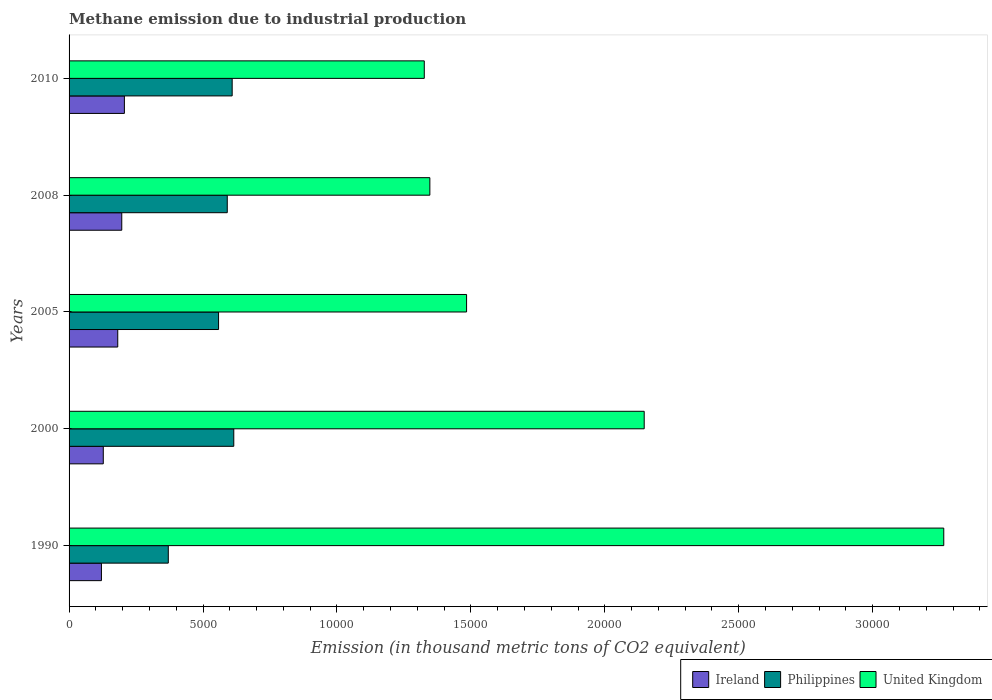How many different coloured bars are there?
Provide a succinct answer. 3. How many groups of bars are there?
Ensure brevity in your answer.  5. Are the number of bars per tick equal to the number of legend labels?
Ensure brevity in your answer.  Yes. How many bars are there on the 4th tick from the top?
Provide a short and direct response. 3. How many bars are there on the 4th tick from the bottom?
Ensure brevity in your answer.  3. What is the label of the 2nd group of bars from the top?
Give a very brief answer. 2008. What is the amount of methane emitted in Ireland in 2010?
Provide a short and direct response. 2065.3. Across all years, what is the maximum amount of methane emitted in Philippines?
Provide a succinct answer. 6149.1. Across all years, what is the minimum amount of methane emitted in United Kingdom?
Provide a short and direct response. 1.33e+04. In which year was the amount of methane emitted in Ireland maximum?
Your answer should be very brief. 2010. What is the total amount of methane emitted in United Kingdom in the graph?
Offer a terse response. 9.57e+04. What is the difference between the amount of methane emitted in Ireland in 2000 and that in 2010?
Give a very brief answer. -788.4. What is the difference between the amount of methane emitted in Ireland in 2000 and the amount of methane emitted in United Kingdom in 2008?
Your answer should be very brief. -1.22e+04. What is the average amount of methane emitted in Ireland per year?
Ensure brevity in your answer.  1667.04. In the year 2000, what is the difference between the amount of methane emitted in United Kingdom and amount of methane emitted in Philippines?
Give a very brief answer. 1.53e+04. In how many years, is the amount of methane emitted in United Kingdom greater than 3000 thousand metric tons?
Make the answer very short. 5. What is the ratio of the amount of methane emitted in United Kingdom in 2000 to that in 2005?
Keep it short and to the point. 1.45. Is the amount of methane emitted in Philippines in 2000 less than that in 2005?
Ensure brevity in your answer.  No. Is the difference between the amount of methane emitted in United Kingdom in 1990 and 2008 greater than the difference between the amount of methane emitted in Philippines in 1990 and 2008?
Give a very brief answer. Yes. What is the difference between the highest and the second highest amount of methane emitted in Ireland?
Offer a very short reply. 98.2. What is the difference between the highest and the lowest amount of methane emitted in Ireland?
Your answer should be very brief. 856.9. In how many years, is the amount of methane emitted in Ireland greater than the average amount of methane emitted in Ireland taken over all years?
Your response must be concise. 3. Is the sum of the amount of methane emitted in Ireland in 1990 and 2000 greater than the maximum amount of methane emitted in United Kingdom across all years?
Your response must be concise. No. Is it the case that in every year, the sum of the amount of methane emitted in Philippines and amount of methane emitted in Ireland is greater than the amount of methane emitted in United Kingdom?
Provide a short and direct response. No. How many bars are there?
Your response must be concise. 15. What is the difference between two consecutive major ticks on the X-axis?
Offer a very short reply. 5000. Where does the legend appear in the graph?
Give a very brief answer. Bottom right. What is the title of the graph?
Give a very brief answer. Methane emission due to industrial production. Does "High income" appear as one of the legend labels in the graph?
Your response must be concise. No. What is the label or title of the X-axis?
Ensure brevity in your answer.  Emission (in thousand metric tons of CO2 equivalent). What is the Emission (in thousand metric tons of CO2 equivalent) in Ireland in 1990?
Give a very brief answer. 1208.4. What is the Emission (in thousand metric tons of CO2 equivalent) in Philippines in 1990?
Keep it short and to the point. 3704.2. What is the Emission (in thousand metric tons of CO2 equivalent) in United Kingdom in 1990?
Your answer should be very brief. 3.27e+04. What is the Emission (in thousand metric tons of CO2 equivalent) in Ireland in 2000?
Offer a very short reply. 1276.9. What is the Emission (in thousand metric tons of CO2 equivalent) in Philippines in 2000?
Offer a very short reply. 6149.1. What is the Emission (in thousand metric tons of CO2 equivalent) in United Kingdom in 2000?
Keep it short and to the point. 2.15e+04. What is the Emission (in thousand metric tons of CO2 equivalent) in Ireland in 2005?
Offer a very short reply. 1817.5. What is the Emission (in thousand metric tons of CO2 equivalent) of Philippines in 2005?
Ensure brevity in your answer.  5580.9. What is the Emission (in thousand metric tons of CO2 equivalent) of United Kingdom in 2005?
Provide a short and direct response. 1.48e+04. What is the Emission (in thousand metric tons of CO2 equivalent) in Ireland in 2008?
Offer a terse response. 1967.1. What is the Emission (in thousand metric tons of CO2 equivalent) of Philippines in 2008?
Provide a succinct answer. 5905.9. What is the Emission (in thousand metric tons of CO2 equivalent) in United Kingdom in 2008?
Ensure brevity in your answer.  1.35e+04. What is the Emission (in thousand metric tons of CO2 equivalent) in Ireland in 2010?
Offer a terse response. 2065.3. What is the Emission (in thousand metric tons of CO2 equivalent) in Philippines in 2010?
Your response must be concise. 6088.8. What is the Emission (in thousand metric tons of CO2 equivalent) of United Kingdom in 2010?
Keep it short and to the point. 1.33e+04. Across all years, what is the maximum Emission (in thousand metric tons of CO2 equivalent) in Ireland?
Make the answer very short. 2065.3. Across all years, what is the maximum Emission (in thousand metric tons of CO2 equivalent) in Philippines?
Offer a terse response. 6149.1. Across all years, what is the maximum Emission (in thousand metric tons of CO2 equivalent) in United Kingdom?
Ensure brevity in your answer.  3.27e+04. Across all years, what is the minimum Emission (in thousand metric tons of CO2 equivalent) in Ireland?
Ensure brevity in your answer.  1208.4. Across all years, what is the minimum Emission (in thousand metric tons of CO2 equivalent) in Philippines?
Give a very brief answer. 3704.2. Across all years, what is the minimum Emission (in thousand metric tons of CO2 equivalent) of United Kingdom?
Provide a short and direct response. 1.33e+04. What is the total Emission (in thousand metric tons of CO2 equivalent) in Ireland in the graph?
Your answer should be very brief. 8335.2. What is the total Emission (in thousand metric tons of CO2 equivalent) of Philippines in the graph?
Give a very brief answer. 2.74e+04. What is the total Emission (in thousand metric tons of CO2 equivalent) in United Kingdom in the graph?
Your answer should be compact. 9.57e+04. What is the difference between the Emission (in thousand metric tons of CO2 equivalent) of Ireland in 1990 and that in 2000?
Your answer should be very brief. -68.5. What is the difference between the Emission (in thousand metric tons of CO2 equivalent) in Philippines in 1990 and that in 2000?
Provide a short and direct response. -2444.9. What is the difference between the Emission (in thousand metric tons of CO2 equivalent) in United Kingdom in 1990 and that in 2000?
Ensure brevity in your answer.  1.12e+04. What is the difference between the Emission (in thousand metric tons of CO2 equivalent) of Ireland in 1990 and that in 2005?
Offer a terse response. -609.1. What is the difference between the Emission (in thousand metric tons of CO2 equivalent) in Philippines in 1990 and that in 2005?
Ensure brevity in your answer.  -1876.7. What is the difference between the Emission (in thousand metric tons of CO2 equivalent) in United Kingdom in 1990 and that in 2005?
Provide a succinct answer. 1.78e+04. What is the difference between the Emission (in thousand metric tons of CO2 equivalent) in Ireland in 1990 and that in 2008?
Keep it short and to the point. -758.7. What is the difference between the Emission (in thousand metric tons of CO2 equivalent) of Philippines in 1990 and that in 2008?
Keep it short and to the point. -2201.7. What is the difference between the Emission (in thousand metric tons of CO2 equivalent) in United Kingdom in 1990 and that in 2008?
Your response must be concise. 1.92e+04. What is the difference between the Emission (in thousand metric tons of CO2 equivalent) in Ireland in 1990 and that in 2010?
Your response must be concise. -856.9. What is the difference between the Emission (in thousand metric tons of CO2 equivalent) in Philippines in 1990 and that in 2010?
Offer a terse response. -2384.6. What is the difference between the Emission (in thousand metric tons of CO2 equivalent) in United Kingdom in 1990 and that in 2010?
Provide a short and direct response. 1.94e+04. What is the difference between the Emission (in thousand metric tons of CO2 equivalent) in Ireland in 2000 and that in 2005?
Ensure brevity in your answer.  -540.6. What is the difference between the Emission (in thousand metric tons of CO2 equivalent) in Philippines in 2000 and that in 2005?
Offer a very short reply. 568.2. What is the difference between the Emission (in thousand metric tons of CO2 equivalent) in United Kingdom in 2000 and that in 2005?
Make the answer very short. 6631. What is the difference between the Emission (in thousand metric tons of CO2 equivalent) of Ireland in 2000 and that in 2008?
Your answer should be compact. -690.2. What is the difference between the Emission (in thousand metric tons of CO2 equivalent) in Philippines in 2000 and that in 2008?
Ensure brevity in your answer.  243.2. What is the difference between the Emission (in thousand metric tons of CO2 equivalent) in United Kingdom in 2000 and that in 2008?
Offer a terse response. 8001.7. What is the difference between the Emission (in thousand metric tons of CO2 equivalent) in Ireland in 2000 and that in 2010?
Your answer should be compact. -788.4. What is the difference between the Emission (in thousand metric tons of CO2 equivalent) of Philippines in 2000 and that in 2010?
Offer a terse response. 60.3. What is the difference between the Emission (in thousand metric tons of CO2 equivalent) in United Kingdom in 2000 and that in 2010?
Your answer should be very brief. 8210. What is the difference between the Emission (in thousand metric tons of CO2 equivalent) of Ireland in 2005 and that in 2008?
Keep it short and to the point. -149.6. What is the difference between the Emission (in thousand metric tons of CO2 equivalent) in Philippines in 2005 and that in 2008?
Give a very brief answer. -325. What is the difference between the Emission (in thousand metric tons of CO2 equivalent) in United Kingdom in 2005 and that in 2008?
Keep it short and to the point. 1370.7. What is the difference between the Emission (in thousand metric tons of CO2 equivalent) in Ireland in 2005 and that in 2010?
Your answer should be compact. -247.8. What is the difference between the Emission (in thousand metric tons of CO2 equivalent) in Philippines in 2005 and that in 2010?
Offer a very short reply. -507.9. What is the difference between the Emission (in thousand metric tons of CO2 equivalent) in United Kingdom in 2005 and that in 2010?
Your response must be concise. 1579. What is the difference between the Emission (in thousand metric tons of CO2 equivalent) in Ireland in 2008 and that in 2010?
Provide a succinct answer. -98.2. What is the difference between the Emission (in thousand metric tons of CO2 equivalent) in Philippines in 2008 and that in 2010?
Offer a terse response. -182.9. What is the difference between the Emission (in thousand metric tons of CO2 equivalent) in United Kingdom in 2008 and that in 2010?
Your answer should be compact. 208.3. What is the difference between the Emission (in thousand metric tons of CO2 equivalent) in Ireland in 1990 and the Emission (in thousand metric tons of CO2 equivalent) in Philippines in 2000?
Offer a very short reply. -4940.7. What is the difference between the Emission (in thousand metric tons of CO2 equivalent) in Ireland in 1990 and the Emission (in thousand metric tons of CO2 equivalent) in United Kingdom in 2000?
Your answer should be compact. -2.03e+04. What is the difference between the Emission (in thousand metric tons of CO2 equivalent) in Philippines in 1990 and the Emission (in thousand metric tons of CO2 equivalent) in United Kingdom in 2000?
Keep it short and to the point. -1.78e+04. What is the difference between the Emission (in thousand metric tons of CO2 equivalent) in Ireland in 1990 and the Emission (in thousand metric tons of CO2 equivalent) in Philippines in 2005?
Keep it short and to the point. -4372.5. What is the difference between the Emission (in thousand metric tons of CO2 equivalent) of Ireland in 1990 and the Emission (in thousand metric tons of CO2 equivalent) of United Kingdom in 2005?
Your answer should be very brief. -1.36e+04. What is the difference between the Emission (in thousand metric tons of CO2 equivalent) of Philippines in 1990 and the Emission (in thousand metric tons of CO2 equivalent) of United Kingdom in 2005?
Your answer should be compact. -1.11e+04. What is the difference between the Emission (in thousand metric tons of CO2 equivalent) in Ireland in 1990 and the Emission (in thousand metric tons of CO2 equivalent) in Philippines in 2008?
Give a very brief answer. -4697.5. What is the difference between the Emission (in thousand metric tons of CO2 equivalent) in Ireland in 1990 and the Emission (in thousand metric tons of CO2 equivalent) in United Kingdom in 2008?
Keep it short and to the point. -1.23e+04. What is the difference between the Emission (in thousand metric tons of CO2 equivalent) of Philippines in 1990 and the Emission (in thousand metric tons of CO2 equivalent) of United Kingdom in 2008?
Your answer should be very brief. -9764.8. What is the difference between the Emission (in thousand metric tons of CO2 equivalent) in Ireland in 1990 and the Emission (in thousand metric tons of CO2 equivalent) in Philippines in 2010?
Keep it short and to the point. -4880.4. What is the difference between the Emission (in thousand metric tons of CO2 equivalent) in Ireland in 1990 and the Emission (in thousand metric tons of CO2 equivalent) in United Kingdom in 2010?
Offer a very short reply. -1.21e+04. What is the difference between the Emission (in thousand metric tons of CO2 equivalent) of Philippines in 1990 and the Emission (in thousand metric tons of CO2 equivalent) of United Kingdom in 2010?
Offer a very short reply. -9556.5. What is the difference between the Emission (in thousand metric tons of CO2 equivalent) in Ireland in 2000 and the Emission (in thousand metric tons of CO2 equivalent) in Philippines in 2005?
Make the answer very short. -4304. What is the difference between the Emission (in thousand metric tons of CO2 equivalent) in Ireland in 2000 and the Emission (in thousand metric tons of CO2 equivalent) in United Kingdom in 2005?
Your answer should be very brief. -1.36e+04. What is the difference between the Emission (in thousand metric tons of CO2 equivalent) of Philippines in 2000 and the Emission (in thousand metric tons of CO2 equivalent) of United Kingdom in 2005?
Make the answer very short. -8690.6. What is the difference between the Emission (in thousand metric tons of CO2 equivalent) in Ireland in 2000 and the Emission (in thousand metric tons of CO2 equivalent) in Philippines in 2008?
Your answer should be compact. -4629. What is the difference between the Emission (in thousand metric tons of CO2 equivalent) of Ireland in 2000 and the Emission (in thousand metric tons of CO2 equivalent) of United Kingdom in 2008?
Give a very brief answer. -1.22e+04. What is the difference between the Emission (in thousand metric tons of CO2 equivalent) in Philippines in 2000 and the Emission (in thousand metric tons of CO2 equivalent) in United Kingdom in 2008?
Offer a very short reply. -7319.9. What is the difference between the Emission (in thousand metric tons of CO2 equivalent) of Ireland in 2000 and the Emission (in thousand metric tons of CO2 equivalent) of Philippines in 2010?
Your answer should be compact. -4811.9. What is the difference between the Emission (in thousand metric tons of CO2 equivalent) in Ireland in 2000 and the Emission (in thousand metric tons of CO2 equivalent) in United Kingdom in 2010?
Offer a terse response. -1.20e+04. What is the difference between the Emission (in thousand metric tons of CO2 equivalent) of Philippines in 2000 and the Emission (in thousand metric tons of CO2 equivalent) of United Kingdom in 2010?
Your response must be concise. -7111.6. What is the difference between the Emission (in thousand metric tons of CO2 equivalent) of Ireland in 2005 and the Emission (in thousand metric tons of CO2 equivalent) of Philippines in 2008?
Ensure brevity in your answer.  -4088.4. What is the difference between the Emission (in thousand metric tons of CO2 equivalent) in Ireland in 2005 and the Emission (in thousand metric tons of CO2 equivalent) in United Kingdom in 2008?
Provide a short and direct response. -1.17e+04. What is the difference between the Emission (in thousand metric tons of CO2 equivalent) of Philippines in 2005 and the Emission (in thousand metric tons of CO2 equivalent) of United Kingdom in 2008?
Make the answer very short. -7888.1. What is the difference between the Emission (in thousand metric tons of CO2 equivalent) of Ireland in 2005 and the Emission (in thousand metric tons of CO2 equivalent) of Philippines in 2010?
Provide a short and direct response. -4271.3. What is the difference between the Emission (in thousand metric tons of CO2 equivalent) of Ireland in 2005 and the Emission (in thousand metric tons of CO2 equivalent) of United Kingdom in 2010?
Provide a succinct answer. -1.14e+04. What is the difference between the Emission (in thousand metric tons of CO2 equivalent) in Philippines in 2005 and the Emission (in thousand metric tons of CO2 equivalent) in United Kingdom in 2010?
Your answer should be very brief. -7679.8. What is the difference between the Emission (in thousand metric tons of CO2 equivalent) in Ireland in 2008 and the Emission (in thousand metric tons of CO2 equivalent) in Philippines in 2010?
Give a very brief answer. -4121.7. What is the difference between the Emission (in thousand metric tons of CO2 equivalent) of Ireland in 2008 and the Emission (in thousand metric tons of CO2 equivalent) of United Kingdom in 2010?
Ensure brevity in your answer.  -1.13e+04. What is the difference between the Emission (in thousand metric tons of CO2 equivalent) of Philippines in 2008 and the Emission (in thousand metric tons of CO2 equivalent) of United Kingdom in 2010?
Offer a terse response. -7354.8. What is the average Emission (in thousand metric tons of CO2 equivalent) of Ireland per year?
Make the answer very short. 1667.04. What is the average Emission (in thousand metric tons of CO2 equivalent) in Philippines per year?
Give a very brief answer. 5485.78. What is the average Emission (in thousand metric tons of CO2 equivalent) of United Kingdom per year?
Give a very brief answer. 1.91e+04. In the year 1990, what is the difference between the Emission (in thousand metric tons of CO2 equivalent) in Ireland and Emission (in thousand metric tons of CO2 equivalent) in Philippines?
Make the answer very short. -2495.8. In the year 1990, what is the difference between the Emission (in thousand metric tons of CO2 equivalent) in Ireland and Emission (in thousand metric tons of CO2 equivalent) in United Kingdom?
Provide a succinct answer. -3.14e+04. In the year 1990, what is the difference between the Emission (in thousand metric tons of CO2 equivalent) of Philippines and Emission (in thousand metric tons of CO2 equivalent) of United Kingdom?
Your response must be concise. -2.89e+04. In the year 2000, what is the difference between the Emission (in thousand metric tons of CO2 equivalent) in Ireland and Emission (in thousand metric tons of CO2 equivalent) in Philippines?
Your answer should be compact. -4872.2. In the year 2000, what is the difference between the Emission (in thousand metric tons of CO2 equivalent) of Ireland and Emission (in thousand metric tons of CO2 equivalent) of United Kingdom?
Provide a short and direct response. -2.02e+04. In the year 2000, what is the difference between the Emission (in thousand metric tons of CO2 equivalent) of Philippines and Emission (in thousand metric tons of CO2 equivalent) of United Kingdom?
Ensure brevity in your answer.  -1.53e+04. In the year 2005, what is the difference between the Emission (in thousand metric tons of CO2 equivalent) of Ireland and Emission (in thousand metric tons of CO2 equivalent) of Philippines?
Give a very brief answer. -3763.4. In the year 2005, what is the difference between the Emission (in thousand metric tons of CO2 equivalent) in Ireland and Emission (in thousand metric tons of CO2 equivalent) in United Kingdom?
Provide a succinct answer. -1.30e+04. In the year 2005, what is the difference between the Emission (in thousand metric tons of CO2 equivalent) in Philippines and Emission (in thousand metric tons of CO2 equivalent) in United Kingdom?
Your response must be concise. -9258.8. In the year 2008, what is the difference between the Emission (in thousand metric tons of CO2 equivalent) in Ireland and Emission (in thousand metric tons of CO2 equivalent) in Philippines?
Your answer should be compact. -3938.8. In the year 2008, what is the difference between the Emission (in thousand metric tons of CO2 equivalent) in Ireland and Emission (in thousand metric tons of CO2 equivalent) in United Kingdom?
Give a very brief answer. -1.15e+04. In the year 2008, what is the difference between the Emission (in thousand metric tons of CO2 equivalent) in Philippines and Emission (in thousand metric tons of CO2 equivalent) in United Kingdom?
Your answer should be very brief. -7563.1. In the year 2010, what is the difference between the Emission (in thousand metric tons of CO2 equivalent) of Ireland and Emission (in thousand metric tons of CO2 equivalent) of Philippines?
Provide a succinct answer. -4023.5. In the year 2010, what is the difference between the Emission (in thousand metric tons of CO2 equivalent) of Ireland and Emission (in thousand metric tons of CO2 equivalent) of United Kingdom?
Your response must be concise. -1.12e+04. In the year 2010, what is the difference between the Emission (in thousand metric tons of CO2 equivalent) in Philippines and Emission (in thousand metric tons of CO2 equivalent) in United Kingdom?
Your response must be concise. -7171.9. What is the ratio of the Emission (in thousand metric tons of CO2 equivalent) of Ireland in 1990 to that in 2000?
Make the answer very short. 0.95. What is the ratio of the Emission (in thousand metric tons of CO2 equivalent) of Philippines in 1990 to that in 2000?
Offer a very short reply. 0.6. What is the ratio of the Emission (in thousand metric tons of CO2 equivalent) of United Kingdom in 1990 to that in 2000?
Your answer should be very brief. 1.52. What is the ratio of the Emission (in thousand metric tons of CO2 equivalent) of Ireland in 1990 to that in 2005?
Keep it short and to the point. 0.66. What is the ratio of the Emission (in thousand metric tons of CO2 equivalent) of Philippines in 1990 to that in 2005?
Keep it short and to the point. 0.66. What is the ratio of the Emission (in thousand metric tons of CO2 equivalent) of United Kingdom in 1990 to that in 2005?
Offer a terse response. 2.2. What is the ratio of the Emission (in thousand metric tons of CO2 equivalent) of Ireland in 1990 to that in 2008?
Offer a very short reply. 0.61. What is the ratio of the Emission (in thousand metric tons of CO2 equivalent) in Philippines in 1990 to that in 2008?
Keep it short and to the point. 0.63. What is the ratio of the Emission (in thousand metric tons of CO2 equivalent) of United Kingdom in 1990 to that in 2008?
Keep it short and to the point. 2.42. What is the ratio of the Emission (in thousand metric tons of CO2 equivalent) in Ireland in 1990 to that in 2010?
Offer a terse response. 0.59. What is the ratio of the Emission (in thousand metric tons of CO2 equivalent) in Philippines in 1990 to that in 2010?
Make the answer very short. 0.61. What is the ratio of the Emission (in thousand metric tons of CO2 equivalent) of United Kingdom in 1990 to that in 2010?
Your answer should be compact. 2.46. What is the ratio of the Emission (in thousand metric tons of CO2 equivalent) in Ireland in 2000 to that in 2005?
Give a very brief answer. 0.7. What is the ratio of the Emission (in thousand metric tons of CO2 equivalent) of Philippines in 2000 to that in 2005?
Make the answer very short. 1.1. What is the ratio of the Emission (in thousand metric tons of CO2 equivalent) of United Kingdom in 2000 to that in 2005?
Your answer should be very brief. 1.45. What is the ratio of the Emission (in thousand metric tons of CO2 equivalent) in Ireland in 2000 to that in 2008?
Give a very brief answer. 0.65. What is the ratio of the Emission (in thousand metric tons of CO2 equivalent) of Philippines in 2000 to that in 2008?
Offer a terse response. 1.04. What is the ratio of the Emission (in thousand metric tons of CO2 equivalent) of United Kingdom in 2000 to that in 2008?
Your answer should be very brief. 1.59. What is the ratio of the Emission (in thousand metric tons of CO2 equivalent) of Ireland in 2000 to that in 2010?
Keep it short and to the point. 0.62. What is the ratio of the Emission (in thousand metric tons of CO2 equivalent) in Philippines in 2000 to that in 2010?
Provide a succinct answer. 1.01. What is the ratio of the Emission (in thousand metric tons of CO2 equivalent) in United Kingdom in 2000 to that in 2010?
Ensure brevity in your answer.  1.62. What is the ratio of the Emission (in thousand metric tons of CO2 equivalent) of Ireland in 2005 to that in 2008?
Offer a terse response. 0.92. What is the ratio of the Emission (in thousand metric tons of CO2 equivalent) in Philippines in 2005 to that in 2008?
Provide a succinct answer. 0.94. What is the ratio of the Emission (in thousand metric tons of CO2 equivalent) in United Kingdom in 2005 to that in 2008?
Provide a short and direct response. 1.1. What is the ratio of the Emission (in thousand metric tons of CO2 equivalent) of Ireland in 2005 to that in 2010?
Offer a terse response. 0.88. What is the ratio of the Emission (in thousand metric tons of CO2 equivalent) in Philippines in 2005 to that in 2010?
Provide a succinct answer. 0.92. What is the ratio of the Emission (in thousand metric tons of CO2 equivalent) in United Kingdom in 2005 to that in 2010?
Your response must be concise. 1.12. What is the ratio of the Emission (in thousand metric tons of CO2 equivalent) of Ireland in 2008 to that in 2010?
Your response must be concise. 0.95. What is the ratio of the Emission (in thousand metric tons of CO2 equivalent) in United Kingdom in 2008 to that in 2010?
Your answer should be compact. 1.02. What is the difference between the highest and the second highest Emission (in thousand metric tons of CO2 equivalent) of Ireland?
Give a very brief answer. 98.2. What is the difference between the highest and the second highest Emission (in thousand metric tons of CO2 equivalent) in Philippines?
Keep it short and to the point. 60.3. What is the difference between the highest and the second highest Emission (in thousand metric tons of CO2 equivalent) in United Kingdom?
Offer a very short reply. 1.12e+04. What is the difference between the highest and the lowest Emission (in thousand metric tons of CO2 equivalent) in Ireland?
Offer a very short reply. 856.9. What is the difference between the highest and the lowest Emission (in thousand metric tons of CO2 equivalent) of Philippines?
Offer a very short reply. 2444.9. What is the difference between the highest and the lowest Emission (in thousand metric tons of CO2 equivalent) of United Kingdom?
Make the answer very short. 1.94e+04. 